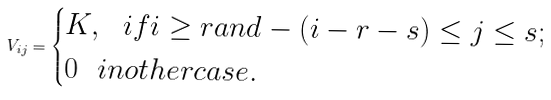Convert formula to latex. <formula><loc_0><loc_0><loc_500><loc_500>V _ { i j } = \begin{cases} K , \ \ i f i \geq r a n d - ( i - r - s ) \leq j \leq s ; \\ 0 \ \ i n o t h e r c a s e . \end{cases}</formula> 